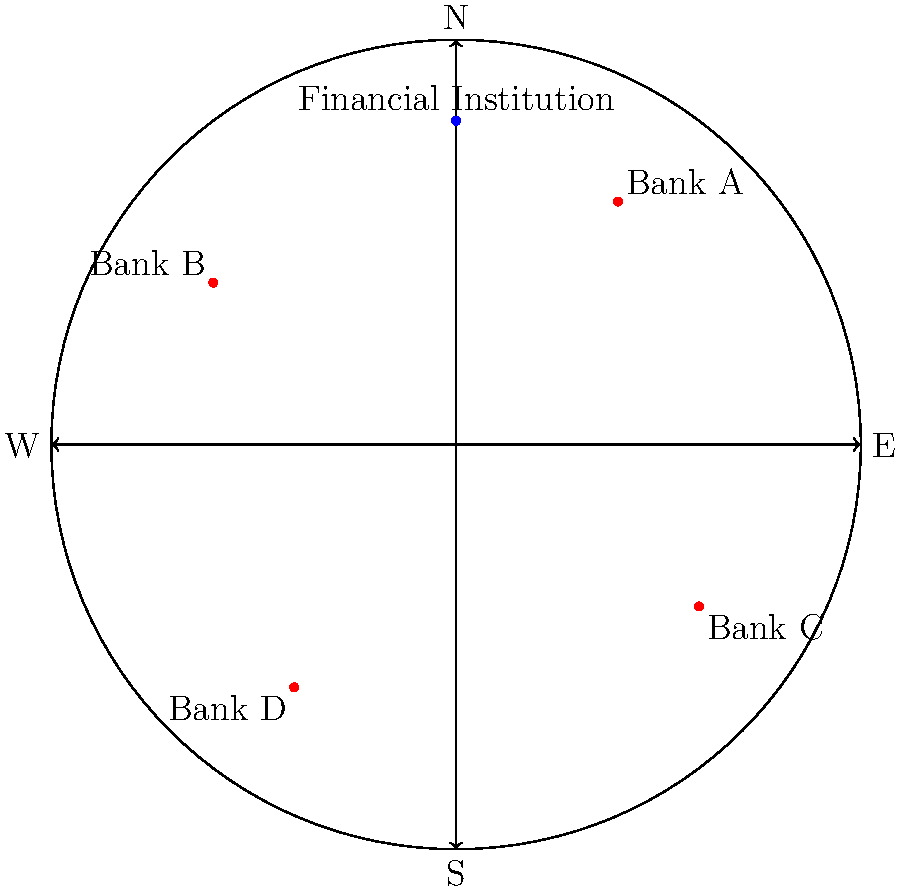Based on the map of Shanghai showing reputable local banks and financial institutions, which bank is located in the southeastern quadrant of the city? To answer this question, we need to follow these steps:

1. Understand the map orientation:
   - The map shows a circular representation of Shanghai with compass directions marked.
   - North (N) is at the top, East (E) is to the right, South (S) is at the bottom, and West (W) is to the left.

2. Identify the southeastern quadrant:
   - The southeastern quadrant would be the area between East and South on the map.

3. Locate the banks on the map:
   - Bank A is in the northeastern quadrant (top-right)
   - Bank B is in the northwestern quadrant (top-left)
   - Bank C is in the southeastern quadrant (bottom-right)
   - Bank D is in the southwestern quadrant (bottom-left)

4. Identify the bank in the southeastern quadrant:
   - Bank C is clearly located in the bottom-right area of the map, which corresponds to the southeastern quadrant.

Therefore, the bank located in the southeastern quadrant of Shanghai, according to this map, is Bank C.
Answer: Bank C 